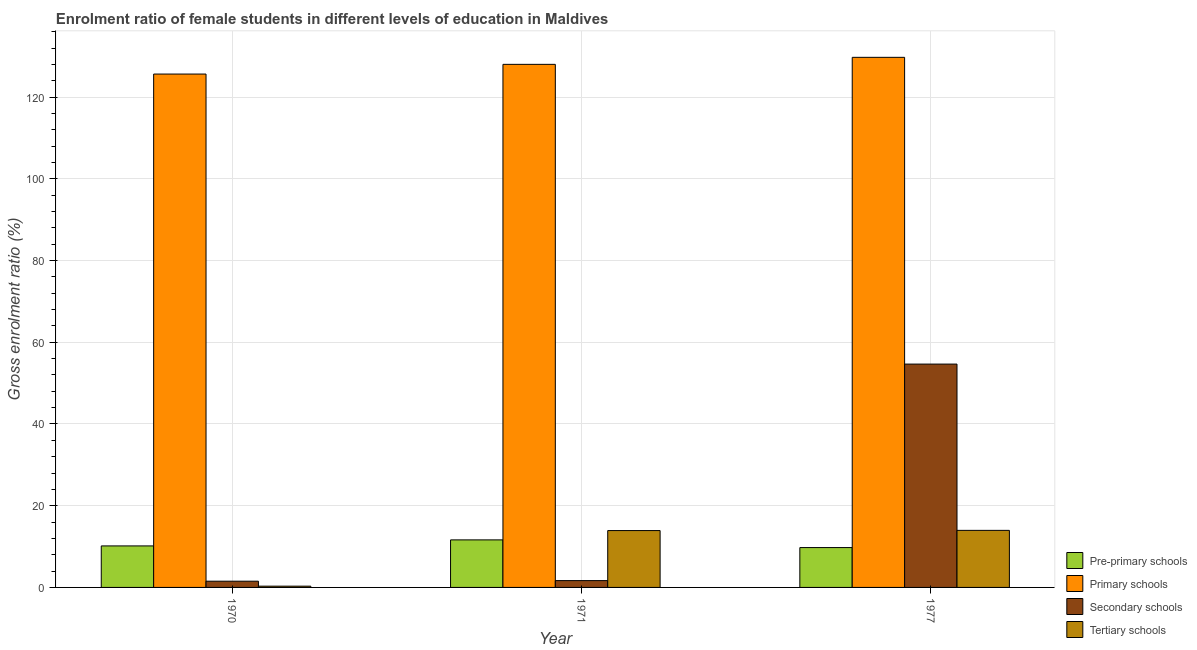How many different coloured bars are there?
Provide a succinct answer. 4. How many groups of bars are there?
Keep it short and to the point. 3. Are the number of bars per tick equal to the number of legend labels?
Make the answer very short. Yes. In how many cases, is the number of bars for a given year not equal to the number of legend labels?
Offer a terse response. 0. What is the gross enrolment ratio(male) in tertiary schools in 1971?
Keep it short and to the point. 13.92. Across all years, what is the maximum gross enrolment ratio(male) in secondary schools?
Ensure brevity in your answer.  54.66. Across all years, what is the minimum gross enrolment ratio(male) in secondary schools?
Your response must be concise. 1.52. In which year was the gross enrolment ratio(male) in primary schools maximum?
Offer a very short reply. 1977. In which year was the gross enrolment ratio(male) in pre-primary schools minimum?
Your response must be concise. 1977. What is the total gross enrolment ratio(male) in tertiary schools in the graph?
Your response must be concise. 28.19. What is the difference between the gross enrolment ratio(male) in primary schools in 1970 and that in 1971?
Keep it short and to the point. -2.38. What is the difference between the gross enrolment ratio(male) in secondary schools in 1971 and the gross enrolment ratio(male) in primary schools in 1977?
Ensure brevity in your answer.  -52.99. What is the average gross enrolment ratio(male) in secondary schools per year?
Provide a succinct answer. 19.29. What is the ratio of the gross enrolment ratio(male) in pre-primary schools in 1970 to that in 1977?
Your answer should be compact. 1.04. Is the gross enrolment ratio(male) in primary schools in 1971 less than that in 1977?
Offer a very short reply. Yes. What is the difference between the highest and the second highest gross enrolment ratio(male) in tertiary schools?
Provide a short and direct response. 0.05. What is the difference between the highest and the lowest gross enrolment ratio(male) in secondary schools?
Keep it short and to the point. 53.14. What does the 1st bar from the left in 1971 represents?
Provide a succinct answer. Pre-primary schools. What does the 1st bar from the right in 1970 represents?
Your response must be concise. Tertiary schools. Is it the case that in every year, the sum of the gross enrolment ratio(male) in pre-primary schools and gross enrolment ratio(male) in primary schools is greater than the gross enrolment ratio(male) in secondary schools?
Keep it short and to the point. Yes. How many bars are there?
Offer a terse response. 12. Are all the bars in the graph horizontal?
Provide a succinct answer. No. How many years are there in the graph?
Provide a short and direct response. 3. What is the difference between two consecutive major ticks on the Y-axis?
Provide a succinct answer. 20. Are the values on the major ticks of Y-axis written in scientific E-notation?
Your answer should be compact. No. Does the graph contain any zero values?
Your response must be concise. No. Does the graph contain grids?
Your answer should be compact. Yes. How many legend labels are there?
Keep it short and to the point. 4. What is the title of the graph?
Your answer should be compact. Enrolment ratio of female students in different levels of education in Maldives. Does "Second 20% of population" appear as one of the legend labels in the graph?
Offer a terse response. No. What is the Gross enrolment ratio (%) in Pre-primary schools in 1970?
Offer a very short reply. 10.16. What is the Gross enrolment ratio (%) of Primary schools in 1970?
Offer a very short reply. 125.65. What is the Gross enrolment ratio (%) in Secondary schools in 1970?
Offer a very short reply. 1.52. What is the Gross enrolment ratio (%) in Tertiary schools in 1970?
Keep it short and to the point. 0.31. What is the Gross enrolment ratio (%) of Pre-primary schools in 1971?
Provide a succinct answer. 11.64. What is the Gross enrolment ratio (%) in Primary schools in 1971?
Keep it short and to the point. 128.02. What is the Gross enrolment ratio (%) of Secondary schools in 1971?
Ensure brevity in your answer.  1.67. What is the Gross enrolment ratio (%) of Tertiary schools in 1971?
Give a very brief answer. 13.92. What is the Gross enrolment ratio (%) of Pre-primary schools in 1977?
Offer a very short reply. 9.76. What is the Gross enrolment ratio (%) in Primary schools in 1977?
Make the answer very short. 129.74. What is the Gross enrolment ratio (%) of Secondary schools in 1977?
Provide a succinct answer. 54.66. What is the Gross enrolment ratio (%) of Tertiary schools in 1977?
Give a very brief answer. 13.97. Across all years, what is the maximum Gross enrolment ratio (%) of Pre-primary schools?
Your answer should be very brief. 11.64. Across all years, what is the maximum Gross enrolment ratio (%) of Primary schools?
Keep it short and to the point. 129.74. Across all years, what is the maximum Gross enrolment ratio (%) of Secondary schools?
Ensure brevity in your answer.  54.66. Across all years, what is the maximum Gross enrolment ratio (%) in Tertiary schools?
Your answer should be very brief. 13.97. Across all years, what is the minimum Gross enrolment ratio (%) of Pre-primary schools?
Offer a terse response. 9.76. Across all years, what is the minimum Gross enrolment ratio (%) in Primary schools?
Your response must be concise. 125.65. Across all years, what is the minimum Gross enrolment ratio (%) of Secondary schools?
Make the answer very short. 1.52. Across all years, what is the minimum Gross enrolment ratio (%) of Tertiary schools?
Provide a short and direct response. 0.31. What is the total Gross enrolment ratio (%) in Pre-primary schools in the graph?
Ensure brevity in your answer.  31.55. What is the total Gross enrolment ratio (%) in Primary schools in the graph?
Provide a short and direct response. 383.41. What is the total Gross enrolment ratio (%) in Secondary schools in the graph?
Your answer should be very brief. 57.86. What is the total Gross enrolment ratio (%) in Tertiary schools in the graph?
Make the answer very short. 28.19. What is the difference between the Gross enrolment ratio (%) of Pre-primary schools in 1970 and that in 1971?
Provide a short and direct response. -1.48. What is the difference between the Gross enrolment ratio (%) of Primary schools in 1970 and that in 1971?
Offer a very short reply. -2.38. What is the difference between the Gross enrolment ratio (%) of Secondary schools in 1970 and that in 1971?
Give a very brief answer. -0.14. What is the difference between the Gross enrolment ratio (%) of Tertiary schools in 1970 and that in 1971?
Provide a short and direct response. -13.61. What is the difference between the Gross enrolment ratio (%) in Pre-primary schools in 1970 and that in 1977?
Keep it short and to the point. 0.4. What is the difference between the Gross enrolment ratio (%) in Primary schools in 1970 and that in 1977?
Give a very brief answer. -4.09. What is the difference between the Gross enrolment ratio (%) of Secondary schools in 1970 and that in 1977?
Your response must be concise. -53.14. What is the difference between the Gross enrolment ratio (%) in Tertiary schools in 1970 and that in 1977?
Ensure brevity in your answer.  -13.66. What is the difference between the Gross enrolment ratio (%) of Pre-primary schools in 1971 and that in 1977?
Give a very brief answer. 1.88. What is the difference between the Gross enrolment ratio (%) of Primary schools in 1971 and that in 1977?
Provide a short and direct response. -1.72. What is the difference between the Gross enrolment ratio (%) of Secondary schools in 1971 and that in 1977?
Make the answer very short. -52.99. What is the difference between the Gross enrolment ratio (%) in Tertiary schools in 1971 and that in 1977?
Ensure brevity in your answer.  -0.05. What is the difference between the Gross enrolment ratio (%) in Pre-primary schools in 1970 and the Gross enrolment ratio (%) in Primary schools in 1971?
Offer a very short reply. -117.86. What is the difference between the Gross enrolment ratio (%) in Pre-primary schools in 1970 and the Gross enrolment ratio (%) in Secondary schools in 1971?
Give a very brief answer. 8.49. What is the difference between the Gross enrolment ratio (%) in Pre-primary schools in 1970 and the Gross enrolment ratio (%) in Tertiary schools in 1971?
Your answer should be compact. -3.76. What is the difference between the Gross enrolment ratio (%) in Primary schools in 1970 and the Gross enrolment ratio (%) in Secondary schools in 1971?
Keep it short and to the point. 123.98. What is the difference between the Gross enrolment ratio (%) of Primary schools in 1970 and the Gross enrolment ratio (%) of Tertiary schools in 1971?
Your answer should be very brief. 111.73. What is the difference between the Gross enrolment ratio (%) of Secondary schools in 1970 and the Gross enrolment ratio (%) of Tertiary schools in 1971?
Make the answer very short. -12.39. What is the difference between the Gross enrolment ratio (%) of Pre-primary schools in 1970 and the Gross enrolment ratio (%) of Primary schools in 1977?
Your answer should be compact. -119.58. What is the difference between the Gross enrolment ratio (%) of Pre-primary schools in 1970 and the Gross enrolment ratio (%) of Secondary schools in 1977?
Ensure brevity in your answer.  -44.5. What is the difference between the Gross enrolment ratio (%) in Pre-primary schools in 1970 and the Gross enrolment ratio (%) in Tertiary schools in 1977?
Give a very brief answer. -3.81. What is the difference between the Gross enrolment ratio (%) of Primary schools in 1970 and the Gross enrolment ratio (%) of Secondary schools in 1977?
Give a very brief answer. 70.98. What is the difference between the Gross enrolment ratio (%) of Primary schools in 1970 and the Gross enrolment ratio (%) of Tertiary schools in 1977?
Your answer should be compact. 111.68. What is the difference between the Gross enrolment ratio (%) in Secondary schools in 1970 and the Gross enrolment ratio (%) in Tertiary schools in 1977?
Provide a succinct answer. -12.44. What is the difference between the Gross enrolment ratio (%) of Pre-primary schools in 1971 and the Gross enrolment ratio (%) of Primary schools in 1977?
Provide a short and direct response. -118.11. What is the difference between the Gross enrolment ratio (%) of Pre-primary schools in 1971 and the Gross enrolment ratio (%) of Secondary schools in 1977?
Provide a succinct answer. -43.03. What is the difference between the Gross enrolment ratio (%) of Pre-primary schools in 1971 and the Gross enrolment ratio (%) of Tertiary schools in 1977?
Offer a terse response. -2.33. What is the difference between the Gross enrolment ratio (%) of Primary schools in 1971 and the Gross enrolment ratio (%) of Secondary schools in 1977?
Provide a short and direct response. 73.36. What is the difference between the Gross enrolment ratio (%) in Primary schools in 1971 and the Gross enrolment ratio (%) in Tertiary schools in 1977?
Keep it short and to the point. 114.06. What is the difference between the Gross enrolment ratio (%) in Secondary schools in 1971 and the Gross enrolment ratio (%) in Tertiary schools in 1977?
Give a very brief answer. -12.3. What is the average Gross enrolment ratio (%) in Pre-primary schools per year?
Provide a short and direct response. 10.52. What is the average Gross enrolment ratio (%) of Primary schools per year?
Provide a short and direct response. 127.8. What is the average Gross enrolment ratio (%) in Secondary schools per year?
Your response must be concise. 19.29. What is the average Gross enrolment ratio (%) of Tertiary schools per year?
Give a very brief answer. 9.4. In the year 1970, what is the difference between the Gross enrolment ratio (%) in Pre-primary schools and Gross enrolment ratio (%) in Primary schools?
Your answer should be very brief. -115.49. In the year 1970, what is the difference between the Gross enrolment ratio (%) of Pre-primary schools and Gross enrolment ratio (%) of Secondary schools?
Offer a terse response. 8.64. In the year 1970, what is the difference between the Gross enrolment ratio (%) in Pre-primary schools and Gross enrolment ratio (%) in Tertiary schools?
Offer a very short reply. 9.85. In the year 1970, what is the difference between the Gross enrolment ratio (%) of Primary schools and Gross enrolment ratio (%) of Secondary schools?
Provide a short and direct response. 124.12. In the year 1970, what is the difference between the Gross enrolment ratio (%) of Primary schools and Gross enrolment ratio (%) of Tertiary schools?
Offer a terse response. 125.34. In the year 1970, what is the difference between the Gross enrolment ratio (%) of Secondary schools and Gross enrolment ratio (%) of Tertiary schools?
Provide a short and direct response. 1.22. In the year 1971, what is the difference between the Gross enrolment ratio (%) in Pre-primary schools and Gross enrolment ratio (%) in Primary schools?
Give a very brief answer. -116.39. In the year 1971, what is the difference between the Gross enrolment ratio (%) of Pre-primary schools and Gross enrolment ratio (%) of Secondary schools?
Ensure brevity in your answer.  9.97. In the year 1971, what is the difference between the Gross enrolment ratio (%) in Pre-primary schools and Gross enrolment ratio (%) in Tertiary schools?
Offer a very short reply. -2.28. In the year 1971, what is the difference between the Gross enrolment ratio (%) in Primary schools and Gross enrolment ratio (%) in Secondary schools?
Give a very brief answer. 126.36. In the year 1971, what is the difference between the Gross enrolment ratio (%) in Primary schools and Gross enrolment ratio (%) in Tertiary schools?
Offer a terse response. 114.11. In the year 1971, what is the difference between the Gross enrolment ratio (%) in Secondary schools and Gross enrolment ratio (%) in Tertiary schools?
Give a very brief answer. -12.25. In the year 1977, what is the difference between the Gross enrolment ratio (%) in Pre-primary schools and Gross enrolment ratio (%) in Primary schools?
Give a very brief answer. -119.98. In the year 1977, what is the difference between the Gross enrolment ratio (%) in Pre-primary schools and Gross enrolment ratio (%) in Secondary schools?
Your answer should be very brief. -44.91. In the year 1977, what is the difference between the Gross enrolment ratio (%) of Pre-primary schools and Gross enrolment ratio (%) of Tertiary schools?
Offer a terse response. -4.21. In the year 1977, what is the difference between the Gross enrolment ratio (%) of Primary schools and Gross enrolment ratio (%) of Secondary schools?
Provide a short and direct response. 75.08. In the year 1977, what is the difference between the Gross enrolment ratio (%) in Primary schools and Gross enrolment ratio (%) in Tertiary schools?
Offer a very short reply. 115.77. In the year 1977, what is the difference between the Gross enrolment ratio (%) in Secondary schools and Gross enrolment ratio (%) in Tertiary schools?
Provide a succinct answer. 40.7. What is the ratio of the Gross enrolment ratio (%) in Pre-primary schools in 1970 to that in 1971?
Give a very brief answer. 0.87. What is the ratio of the Gross enrolment ratio (%) in Primary schools in 1970 to that in 1971?
Keep it short and to the point. 0.98. What is the ratio of the Gross enrolment ratio (%) of Secondary schools in 1970 to that in 1971?
Offer a very short reply. 0.91. What is the ratio of the Gross enrolment ratio (%) of Tertiary schools in 1970 to that in 1971?
Provide a succinct answer. 0.02. What is the ratio of the Gross enrolment ratio (%) in Pre-primary schools in 1970 to that in 1977?
Provide a succinct answer. 1.04. What is the ratio of the Gross enrolment ratio (%) in Primary schools in 1970 to that in 1977?
Give a very brief answer. 0.97. What is the ratio of the Gross enrolment ratio (%) of Secondary schools in 1970 to that in 1977?
Provide a succinct answer. 0.03. What is the ratio of the Gross enrolment ratio (%) in Tertiary schools in 1970 to that in 1977?
Offer a very short reply. 0.02. What is the ratio of the Gross enrolment ratio (%) in Pre-primary schools in 1971 to that in 1977?
Your answer should be very brief. 1.19. What is the ratio of the Gross enrolment ratio (%) in Secondary schools in 1971 to that in 1977?
Give a very brief answer. 0.03. What is the ratio of the Gross enrolment ratio (%) in Tertiary schools in 1971 to that in 1977?
Ensure brevity in your answer.  1. What is the difference between the highest and the second highest Gross enrolment ratio (%) in Pre-primary schools?
Offer a very short reply. 1.48. What is the difference between the highest and the second highest Gross enrolment ratio (%) of Primary schools?
Give a very brief answer. 1.72. What is the difference between the highest and the second highest Gross enrolment ratio (%) of Secondary schools?
Your answer should be compact. 52.99. What is the difference between the highest and the second highest Gross enrolment ratio (%) of Tertiary schools?
Your answer should be very brief. 0.05. What is the difference between the highest and the lowest Gross enrolment ratio (%) of Pre-primary schools?
Make the answer very short. 1.88. What is the difference between the highest and the lowest Gross enrolment ratio (%) of Primary schools?
Give a very brief answer. 4.09. What is the difference between the highest and the lowest Gross enrolment ratio (%) in Secondary schools?
Your answer should be compact. 53.14. What is the difference between the highest and the lowest Gross enrolment ratio (%) of Tertiary schools?
Provide a succinct answer. 13.66. 